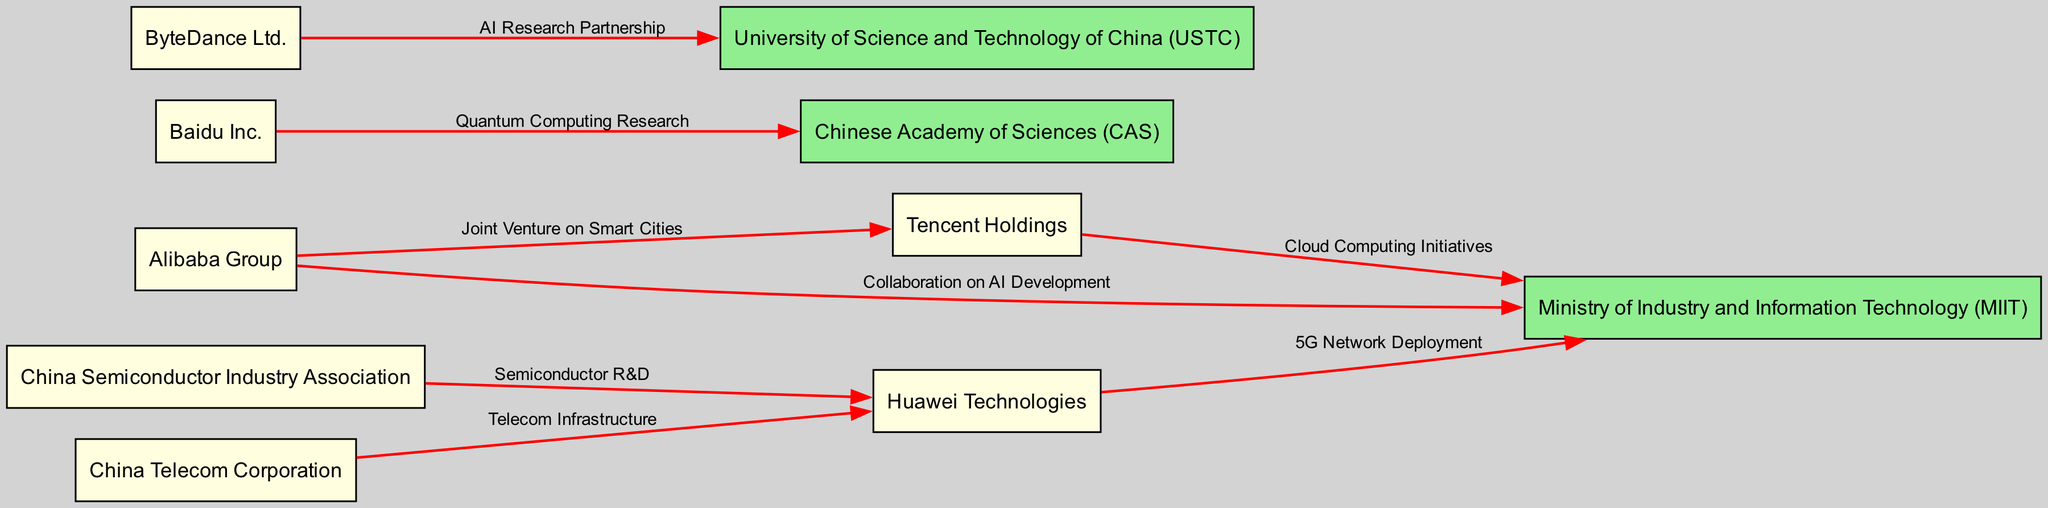What is the total number of nodes in the diagram? The diagram lists several entities as nodes, including both companies and government bodies. By counting each of the entry names presented, there are a total of ten distinct nodes in the diagram.
Answer: 10 Which company collaborates with the Ministry of Industry and Information Technology on AI Development? By examining the edges connected to the Ministry of Industry and Information Technology (MIIT), we see that Alibaba Group has a direct edge labeled "Collaboration on AI Development." Therefore, Alibaba Group is the company in question.
Answer: Alibaba Group How many collaborations involve the Chinese Academy of Sciences? Upon reviewing the edges stemming from the Chinese Academy of Sciences (CAS), there is only one collaboration mentioned, which is with Baidu Inc. regarding "Quantum Computing Research." Therefore, there is one collaboration tied to this organization.
Answer: 1 What type of research partnership does ByteDance Ltd. engage in with the University of Science and Technology of China? Looking at the edge connecting ByteDance Ltd. to the University of Science and Technology of China (USTC), it is clearly labeled as an "AI Research Partnership." This information directly identifies the nature of their collaboration.
Answer: AI Research Partnership Which two companies have a joint venture focusing on smart cities? The edge shows a connection between Alibaba Group and Tencent Holdings that indicates a joint venture specifically labeled for "Smart Cities." This directly highlights the two companies involved in this initiative.
Answer: Alibaba Group and Tencent Holdings What is the primary focus of the collaboration between Huawei Technologies and the Ministry of Industry and Information Technology? When reviewing the edge connecting Huawei Technologies to the Ministry of Industry and Information Technology (MIIT), the label indicates that their primary focus is on "5G Network Deployment." This provides a clear description of their collaboration’s aim.
Answer: 5G Network Deployment Which organization is connected to a semiconductor research and development initiative with Huawei? The edge from the China Semiconductor Industry Association to Huawei Technologies is labeled "Semiconductor R&D," which explicitly indicates that this organization is involved in semiconductor research and development with Huawei.
Answer: China Semiconductor Industry Association How many total collaborations are mentioned in the diagram? By tallying the edges that represent collaborations in the diagram, we find a total of seven edges. Each edge signifies a connection that represents a unique collaboration, helping to quantify the relationships visually.
Answer: 7 What color represents the nodes corresponding to government organizations? The nodes in the diagram that represent government organizations, including the Ministry of Industry and Information Technology, Chinese Academy of Sciences, and University of Science and Technology of China, are colored light green as per the node styling criteria defined in the diagram.
Answer: Light green 